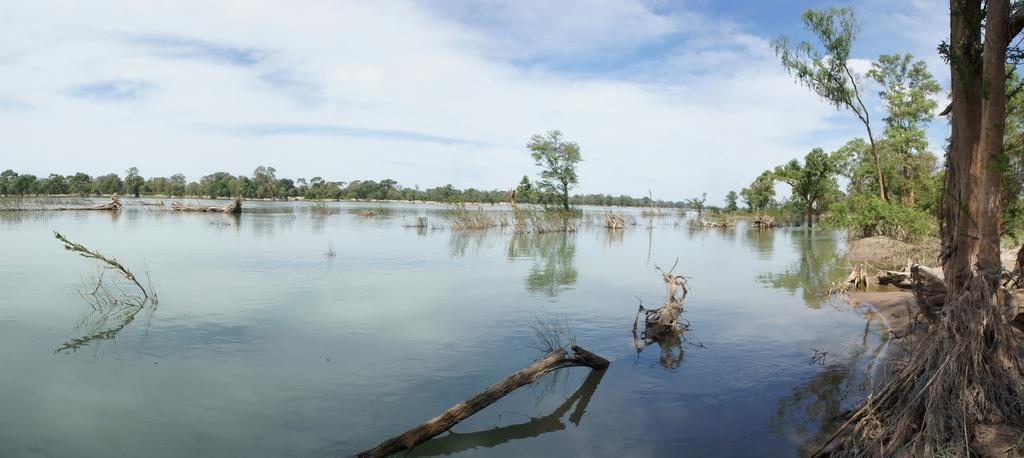Please provide a concise description of this image. At the bottom of the image there is water with sticks and few plants in the water. In the background there are trees. At the top of the image there is a sky with clouds. 